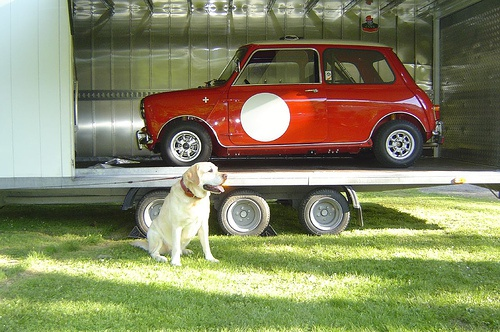Describe the objects in this image and their specific colors. I can see truck in ivory, black, gray, lightgray, and darkgreen tones, car in ivory, brown, black, maroon, and white tones, and dog in ivory, beige, tan, and darkgray tones in this image. 